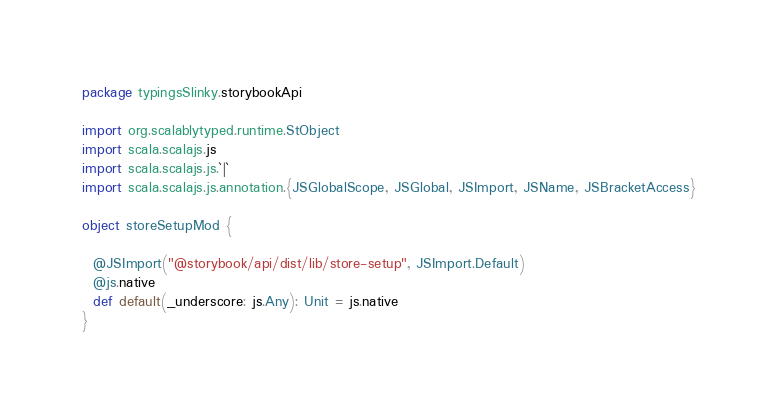<code> <loc_0><loc_0><loc_500><loc_500><_Scala_>package typingsSlinky.storybookApi

import org.scalablytyped.runtime.StObject
import scala.scalajs.js
import scala.scalajs.js.`|`
import scala.scalajs.js.annotation.{JSGlobalScope, JSGlobal, JSImport, JSName, JSBracketAccess}

object storeSetupMod {
  
  @JSImport("@storybook/api/dist/lib/store-setup", JSImport.Default)
  @js.native
  def default(_underscore: js.Any): Unit = js.native
}
</code> 